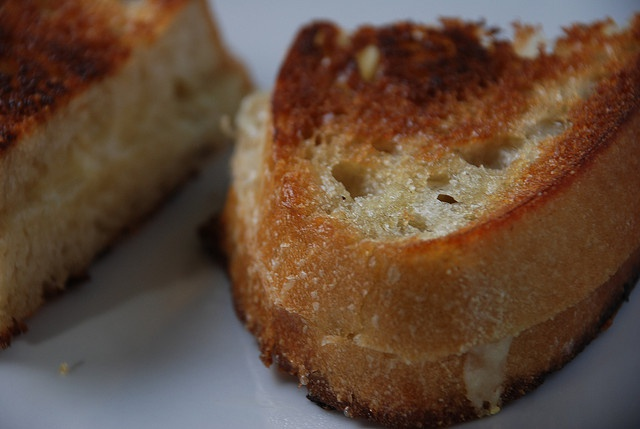Describe the objects in this image and their specific colors. I can see sandwich in maroon, brown, and black tones, sandwich in maroon, black, and gray tones, and cake in maroon, black, and gray tones in this image. 